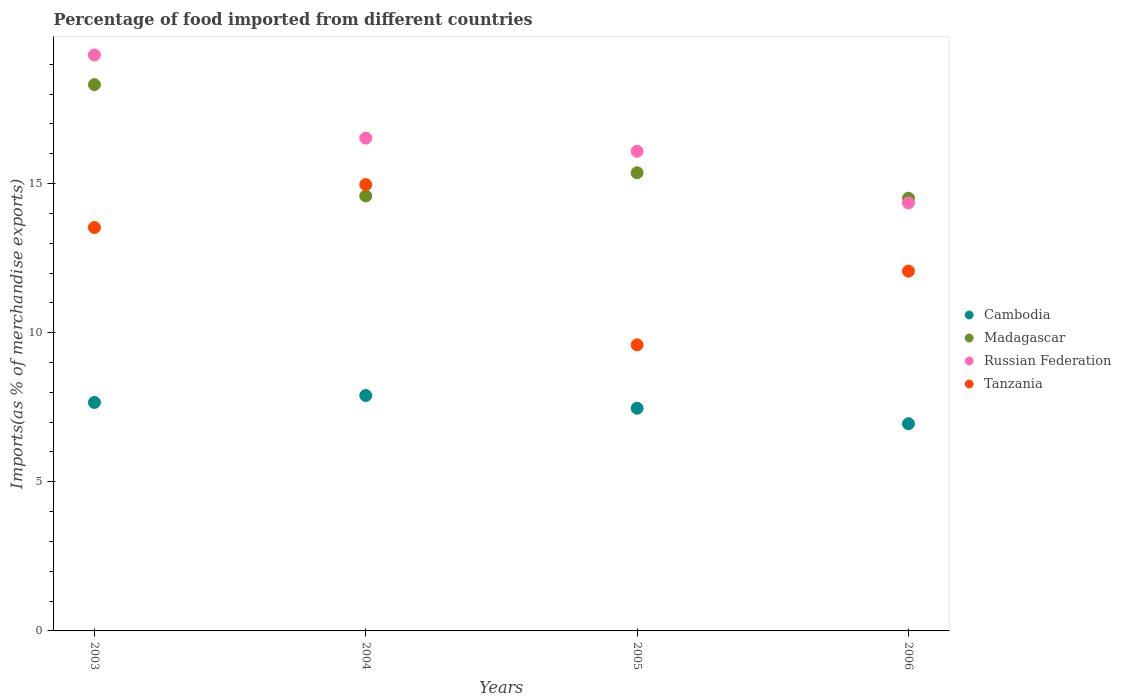How many different coloured dotlines are there?
Offer a terse response. 4. Is the number of dotlines equal to the number of legend labels?
Your answer should be very brief. Yes. What is the percentage of imports to different countries in Tanzania in 2004?
Your answer should be compact. 14.97. Across all years, what is the maximum percentage of imports to different countries in Cambodia?
Your answer should be compact. 7.89. Across all years, what is the minimum percentage of imports to different countries in Madagascar?
Provide a short and direct response. 14.51. What is the total percentage of imports to different countries in Russian Federation in the graph?
Keep it short and to the point. 66.27. What is the difference between the percentage of imports to different countries in Tanzania in 2004 and that in 2006?
Your answer should be very brief. 2.9. What is the difference between the percentage of imports to different countries in Madagascar in 2006 and the percentage of imports to different countries in Tanzania in 2004?
Make the answer very short. -0.46. What is the average percentage of imports to different countries in Madagascar per year?
Ensure brevity in your answer.  15.69. In the year 2004, what is the difference between the percentage of imports to different countries in Madagascar and percentage of imports to different countries in Cambodia?
Give a very brief answer. 6.69. In how many years, is the percentage of imports to different countries in Madagascar greater than 16 %?
Give a very brief answer. 1. What is the ratio of the percentage of imports to different countries in Tanzania in 2003 to that in 2006?
Your answer should be very brief. 1.12. What is the difference between the highest and the second highest percentage of imports to different countries in Russian Federation?
Ensure brevity in your answer.  2.79. What is the difference between the highest and the lowest percentage of imports to different countries in Tanzania?
Make the answer very short. 5.37. Does the percentage of imports to different countries in Madagascar monotonically increase over the years?
Your response must be concise. No. Is the percentage of imports to different countries in Madagascar strictly greater than the percentage of imports to different countries in Tanzania over the years?
Offer a terse response. No. How many years are there in the graph?
Ensure brevity in your answer.  4. Where does the legend appear in the graph?
Your answer should be very brief. Center right. What is the title of the graph?
Your response must be concise. Percentage of food imported from different countries. Does "St. Lucia" appear as one of the legend labels in the graph?
Make the answer very short. No. What is the label or title of the X-axis?
Offer a terse response. Years. What is the label or title of the Y-axis?
Give a very brief answer. Imports(as % of merchandise exports). What is the Imports(as % of merchandise exports) in Cambodia in 2003?
Your response must be concise. 7.66. What is the Imports(as % of merchandise exports) of Madagascar in 2003?
Provide a succinct answer. 18.32. What is the Imports(as % of merchandise exports) of Russian Federation in 2003?
Your answer should be compact. 19.31. What is the Imports(as % of merchandise exports) of Tanzania in 2003?
Offer a very short reply. 13.53. What is the Imports(as % of merchandise exports) in Cambodia in 2004?
Provide a succinct answer. 7.89. What is the Imports(as % of merchandise exports) of Madagascar in 2004?
Keep it short and to the point. 14.59. What is the Imports(as % of merchandise exports) of Russian Federation in 2004?
Provide a short and direct response. 16.52. What is the Imports(as % of merchandise exports) in Tanzania in 2004?
Your answer should be very brief. 14.97. What is the Imports(as % of merchandise exports) in Cambodia in 2005?
Offer a terse response. 7.47. What is the Imports(as % of merchandise exports) in Madagascar in 2005?
Ensure brevity in your answer.  15.36. What is the Imports(as % of merchandise exports) of Russian Federation in 2005?
Make the answer very short. 16.08. What is the Imports(as % of merchandise exports) in Tanzania in 2005?
Make the answer very short. 9.59. What is the Imports(as % of merchandise exports) of Cambodia in 2006?
Offer a very short reply. 6.95. What is the Imports(as % of merchandise exports) of Madagascar in 2006?
Keep it short and to the point. 14.51. What is the Imports(as % of merchandise exports) of Russian Federation in 2006?
Give a very brief answer. 14.35. What is the Imports(as % of merchandise exports) of Tanzania in 2006?
Offer a very short reply. 12.06. Across all years, what is the maximum Imports(as % of merchandise exports) in Cambodia?
Give a very brief answer. 7.89. Across all years, what is the maximum Imports(as % of merchandise exports) in Madagascar?
Offer a very short reply. 18.32. Across all years, what is the maximum Imports(as % of merchandise exports) in Russian Federation?
Provide a succinct answer. 19.31. Across all years, what is the maximum Imports(as % of merchandise exports) of Tanzania?
Your answer should be very brief. 14.97. Across all years, what is the minimum Imports(as % of merchandise exports) of Cambodia?
Your answer should be compact. 6.95. Across all years, what is the minimum Imports(as % of merchandise exports) in Madagascar?
Offer a very short reply. 14.51. Across all years, what is the minimum Imports(as % of merchandise exports) of Russian Federation?
Your response must be concise. 14.35. Across all years, what is the minimum Imports(as % of merchandise exports) of Tanzania?
Offer a terse response. 9.59. What is the total Imports(as % of merchandise exports) of Cambodia in the graph?
Offer a very short reply. 29.97. What is the total Imports(as % of merchandise exports) of Madagascar in the graph?
Give a very brief answer. 62.78. What is the total Imports(as % of merchandise exports) in Russian Federation in the graph?
Provide a succinct answer. 66.27. What is the total Imports(as % of merchandise exports) of Tanzania in the graph?
Your answer should be compact. 50.15. What is the difference between the Imports(as % of merchandise exports) in Cambodia in 2003 and that in 2004?
Your answer should be very brief. -0.23. What is the difference between the Imports(as % of merchandise exports) in Madagascar in 2003 and that in 2004?
Offer a very short reply. 3.73. What is the difference between the Imports(as % of merchandise exports) in Russian Federation in 2003 and that in 2004?
Offer a very short reply. 2.79. What is the difference between the Imports(as % of merchandise exports) in Tanzania in 2003 and that in 2004?
Offer a terse response. -1.44. What is the difference between the Imports(as % of merchandise exports) in Cambodia in 2003 and that in 2005?
Provide a succinct answer. 0.19. What is the difference between the Imports(as % of merchandise exports) in Madagascar in 2003 and that in 2005?
Your response must be concise. 2.95. What is the difference between the Imports(as % of merchandise exports) in Russian Federation in 2003 and that in 2005?
Your answer should be very brief. 3.23. What is the difference between the Imports(as % of merchandise exports) in Tanzania in 2003 and that in 2005?
Your answer should be very brief. 3.93. What is the difference between the Imports(as % of merchandise exports) in Cambodia in 2003 and that in 2006?
Ensure brevity in your answer.  0.71. What is the difference between the Imports(as % of merchandise exports) of Madagascar in 2003 and that in 2006?
Provide a short and direct response. 3.81. What is the difference between the Imports(as % of merchandise exports) of Russian Federation in 2003 and that in 2006?
Offer a terse response. 4.96. What is the difference between the Imports(as % of merchandise exports) in Tanzania in 2003 and that in 2006?
Offer a very short reply. 1.46. What is the difference between the Imports(as % of merchandise exports) in Cambodia in 2004 and that in 2005?
Offer a terse response. 0.43. What is the difference between the Imports(as % of merchandise exports) in Madagascar in 2004 and that in 2005?
Your response must be concise. -0.78. What is the difference between the Imports(as % of merchandise exports) in Russian Federation in 2004 and that in 2005?
Give a very brief answer. 0.44. What is the difference between the Imports(as % of merchandise exports) in Tanzania in 2004 and that in 2005?
Your answer should be very brief. 5.37. What is the difference between the Imports(as % of merchandise exports) in Cambodia in 2004 and that in 2006?
Provide a short and direct response. 0.95. What is the difference between the Imports(as % of merchandise exports) in Madagascar in 2004 and that in 2006?
Ensure brevity in your answer.  0.08. What is the difference between the Imports(as % of merchandise exports) of Russian Federation in 2004 and that in 2006?
Offer a terse response. 2.17. What is the difference between the Imports(as % of merchandise exports) in Tanzania in 2004 and that in 2006?
Your answer should be compact. 2.9. What is the difference between the Imports(as % of merchandise exports) of Cambodia in 2005 and that in 2006?
Ensure brevity in your answer.  0.52. What is the difference between the Imports(as % of merchandise exports) in Madagascar in 2005 and that in 2006?
Your response must be concise. 0.85. What is the difference between the Imports(as % of merchandise exports) of Russian Federation in 2005 and that in 2006?
Keep it short and to the point. 1.73. What is the difference between the Imports(as % of merchandise exports) in Tanzania in 2005 and that in 2006?
Your response must be concise. -2.47. What is the difference between the Imports(as % of merchandise exports) in Cambodia in 2003 and the Imports(as % of merchandise exports) in Madagascar in 2004?
Offer a very short reply. -6.92. What is the difference between the Imports(as % of merchandise exports) in Cambodia in 2003 and the Imports(as % of merchandise exports) in Russian Federation in 2004?
Your response must be concise. -8.86. What is the difference between the Imports(as % of merchandise exports) of Cambodia in 2003 and the Imports(as % of merchandise exports) of Tanzania in 2004?
Ensure brevity in your answer.  -7.3. What is the difference between the Imports(as % of merchandise exports) of Madagascar in 2003 and the Imports(as % of merchandise exports) of Russian Federation in 2004?
Give a very brief answer. 1.79. What is the difference between the Imports(as % of merchandise exports) of Madagascar in 2003 and the Imports(as % of merchandise exports) of Tanzania in 2004?
Give a very brief answer. 3.35. What is the difference between the Imports(as % of merchandise exports) in Russian Federation in 2003 and the Imports(as % of merchandise exports) in Tanzania in 2004?
Your answer should be compact. 4.35. What is the difference between the Imports(as % of merchandise exports) of Cambodia in 2003 and the Imports(as % of merchandise exports) of Madagascar in 2005?
Your answer should be very brief. -7.7. What is the difference between the Imports(as % of merchandise exports) of Cambodia in 2003 and the Imports(as % of merchandise exports) of Russian Federation in 2005?
Your answer should be compact. -8.42. What is the difference between the Imports(as % of merchandise exports) of Cambodia in 2003 and the Imports(as % of merchandise exports) of Tanzania in 2005?
Provide a succinct answer. -1.93. What is the difference between the Imports(as % of merchandise exports) of Madagascar in 2003 and the Imports(as % of merchandise exports) of Russian Federation in 2005?
Ensure brevity in your answer.  2.23. What is the difference between the Imports(as % of merchandise exports) of Madagascar in 2003 and the Imports(as % of merchandise exports) of Tanzania in 2005?
Keep it short and to the point. 8.73. What is the difference between the Imports(as % of merchandise exports) of Russian Federation in 2003 and the Imports(as % of merchandise exports) of Tanzania in 2005?
Keep it short and to the point. 9.72. What is the difference between the Imports(as % of merchandise exports) of Cambodia in 2003 and the Imports(as % of merchandise exports) of Madagascar in 2006?
Make the answer very short. -6.85. What is the difference between the Imports(as % of merchandise exports) of Cambodia in 2003 and the Imports(as % of merchandise exports) of Russian Federation in 2006?
Provide a succinct answer. -6.69. What is the difference between the Imports(as % of merchandise exports) in Cambodia in 2003 and the Imports(as % of merchandise exports) in Tanzania in 2006?
Ensure brevity in your answer.  -4.4. What is the difference between the Imports(as % of merchandise exports) in Madagascar in 2003 and the Imports(as % of merchandise exports) in Russian Federation in 2006?
Give a very brief answer. 3.97. What is the difference between the Imports(as % of merchandise exports) of Madagascar in 2003 and the Imports(as % of merchandise exports) of Tanzania in 2006?
Offer a terse response. 6.25. What is the difference between the Imports(as % of merchandise exports) in Russian Federation in 2003 and the Imports(as % of merchandise exports) in Tanzania in 2006?
Ensure brevity in your answer.  7.25. What is the difference between the Imports(as % of merchandise exports) in Cambodia in 2004 and the Imports(as % of merchandise exports) in Madagascar in 2005?
Keep it short and to the point. -7.47. What is the difference between the Imports(as % of merchandise exports) of Cambodia in 2004 and the Imports(as % of merchandise exports) of Russian Federation in 2005?
Make the answer very short. -8.19. What is the difference between the Imports(as % of merchandise exports) in Cambodia in 2004 and the Imports(as % of merchandise exports) in Tanzania in 2005?
Provide a succinct answer. -1.7. What is the difference between the Imports(as % of merchandise exports) in Madagascar in 2004 and the Imports(as % of merchandise exports) in Russian Federation in 2005?
Your answer should be very brief. -1.5. What is the difference between the Imports(as % of merchandise exports) in Madagascar in 2004 and the Imports(as % of merchandise exports) in Tanzania in 2005?
Your response must be concise. 4.99. What is the difference between the Imports(as % of merchandise exports) in Russian Federation in 2004 and the Imports(as % of merchandise exports) in Tanzania in 2005?
Give a very brief answer. 6.93. What is the difference between the Imports(as % of merchandise exports) of Cambodia in 2004 and the Imports(as % of merchandise exports) of Madagascar in 2006?
Ensure brevity in your answer.  -6.62. What is the difference between the Imports(as % of merchandise exports) of Cambodia in 2004 and the Imports(as % of merchandise exports) of Russian Federation in 2006?
Give a very brief answer. -6.46. What is the difference between the Imports(as % of merchandise exports) of Cambodia in 2004 and the Imports(as % of merchandise exports) of Tanzania in 2006?
Ensure brevity in your answer.  -4.17. What is the difference between the Imports(as % of merchandise exports) in Madagascar in 2004 and the Imports(as % of merchandise exports) in Russian Federation in 2006?
Provide a succinct answer. 0.23. What is the difference between the Imports(as % of merchandise exports) in Madagascar in 2004 and the Imports(as % of merchandise exports) in Tanzania in 2006?
Your answer should be compact. 2.52. What is the difference between the Imports(as % of merchandise exports) of Russian Federation in 2004 and the Imports(as % of merchandise exports) of Tanzania in 2006?
Your answer should be very brief. 4.46. What is the difference between the Imports(as % of merchandise exports) in Cambodia in 2005 and the Imports(as % of merchandise exports) in Madagascar in 2006?
Provide a short and direct response. -7.04. What is the difference between the Imports(as % of merchandise exports) of Cambodia in 2005 and the Imports(as % of merchandise exports) of Russian Federation in 2006?
Make the answer very short. -6.88. What is the difference between the Imports(as % of merchandise exports) of Cambodia in 2005 and the Imports(as % of merchandise exports) of Tanzania in 2006?
Make the answer very short. -4.6. What is the difference between the Imports(as % of merchandise exports) of Madagascar in 2005 and the Imports(as % of merchandise exports) of Russian Federation in 2006?
Offer a terse response. 1.01. What is the difference between the Imports(as % of merchandise exports) of Madagascar in 2005 and the Imports(as % of merchandise exports) of Tanzania in 2006?
Provide a short and direct response. 3.3. What is the difference between the Imports(as % of merchandise exports) in Russian Federation in 2005 and the Imports(as % of merchandise exports) in Tanzania in 2006?
Keep it short and to the point. 4.02. What is the average Imports(as % of merchandise exports) of Cambodia per year?
Offer a very short reply. 7.49. What is the average Imports(as % of merchandise exports) of Madagascar per year?
Provide a succinct answer. 15.69. What is the average Imports(as % of merchandise exports) of Russian Federation per year?
Ensure brevity in your answer.  16.57. What is the average Imports(as % of merchandise exports) in Tanzania per year?
Your answer should be compact. 12.54. In the year 2003, what is the difference between the Imports(as % of merchandise exports) of Cambodia and Imports(as % of merchandise exports) of Madagascar?
Make the answer very short. -10.66. In the year 2003, what is the difference between the Imports(as % of merchandise exports) in Cambodia and Imports(as % of merchandise exports) in Russian Federation?
Make the answer very short. -11.65. In the year 2003, what is the difference between the Imports(as % of merchandise exports) in Cambodia and Imports(as % of merchandise exports) in Tanzania?
Provide a short and direct response. -5.87. In the year 2003, what is the difference between the Imports(as % of merchandise exports) in Madagascar and Imports(as % of merchandise exports) in Russian Federation?
Keep it short and to the point. -0.99. In the year 2003, what is the difference between the Imports(as % of merchandise exports) of Madagascar and Imports(as % of merchandise exports) of Tanzania?
Your response must be concise. 4.79. In the year 2003, what is the difference between the Imports(as % of merchandise exports) in Russian Federation and Imports(as % of merchandise exports) in Tanzania?
Make the answer very short. 5.78. In the year 2004, what is the difference between the Imports(as % of merchandise exports) in Cambodia and Imports(as % of merchandise exports) in Madagascar?
Your response must be concise. -6.69. In the year 2004, what is the difference between the Imports(as % of merchandise exports) of Cambodia and Imports(as % of merchandise exports) of Russian Federation?
Offer a very short reply. -8.63. In the year 2004, what is the difference between the Imports(as % of merchandise exports) of Cambodia and Imports(as % of merchandise exports) of Tanzania?
Ensure brevity in your answer.  -7.07. In the year 2004, what is the difference between the Imports(as % of merchandise exports) of Madagascar and Imports(as % of merchandise exports) of Russian Federation?
Keep it short and to the point. -1.94. In the year 2004, what is the difference between the Imports(as % of merchandise exports) of Madagascar and Imports(as % of merchandise exports) of Tanzania?
Make the answer very short. -0.38. In the year 2004, what is the difference between the Imports(as % of merchandise exports) in Russian Federation and Imports(as % of merchandise exports) in Tanzania?
Offer a terse response. 1.56. In the year 2005, what is the difference between the Imports(as % of merchandise exports) of Cambodia and Imports(as % of merchandise exports) of Madagascar?
Provide a short and direct response. -7.9. In the year 2005, what is the difference between the Imports(as % of merchandise exports) in Cambodia and Imports(as % of merchandise exports) in Russian Federation?
Make the answer very short. -8.62. In the year 2005, what is the difference between the Imports(as % of merchandise exports) in Cambodia and Imports(as % of merchandise exports) in Tanzania?
Your answer should be very brief. -2.13. In the year 2005, what is the difference between the Imports(as % of merchandise exports) of Madagascar and Imports(as % of merchandise exports) of Russian Federation?
Keep it short and to the point. -0.72. In the year 2005, what is the difference between the Imports(as % of merchandise exports) in Madagascar and Imports(as % of merchandise exports) in Tanzania?
Keep it short and to the point. 5.77. In the year 2005, what is the difference between the Imports(as % of merchandise exports) in Russian Federation and Imports(as % of merchandise exports) in Tanzania?
Your answer should be very brief. 6.49. In the year 2006, what is the difference between the Imports(as % of merchandise exports) in Cambodia and Imports(as % of merchandise exports) in Madagascar?
Ensure brevity in your answer.  -7.56. In the year 2006, what is the difference between the Imports(as % of merchandise exports) of Cambodia and Imports(as % of merchandise exports) of Russian Federation?
Provide a succinct answer. -7.4. In the year 2006, what is the difference between the Imports(as % of merchandise exports) of Cambodia and Imports(as % of merchandise exports) of Tanzania?
Your answer should be compact. -5.12. In the year 2006, what is the difference between the Imports(as % of merchandise exports) in Madagascar and Imports(as % of merchandise exports) in Russian Federation?
Ensure brevity in your answer.  0.16. In the year 2006, what is the difference between the Imports(as % of merchandise exports) of Madagascar and Imports(as % of merchandise exports) of Tanzania?
Your answer should be compact. 2.45. In the year 2006, what is the difference between the Imports(as % of merchandise exports) in Russian Federation and Imports(as % of merchandise exports) in Tanzania?
Provide a short and direct response. 2.29. What is the ratio of the Imports(as % of merchandise exports) in Cambodia in 2003 to that in 2004?
Offer a terse response. 0.97. What is the ratio of the Imports(as % of merchandise exports) of Madagascar in 2003 to that in 2004?
Your response must be concise. 1.26. What is the ratio of the Imports(as % of merchandise exports) in Russian Federation in 2003 to that in 2004?
Ensure brevity in your answer.  1.17. What is the ratio of the Imports(as % of merchandise exports) in Tanzania in 2003 to that in 2004?
Make the answer very short. 0.9. What is the ratio of the Imports(as % of merchandise exports) in Cambodia in 2003 to that in 2005?
Ensure brevity in your answer.  1.03. What is the ratio of the Imports(as % of merchandise exports) in Madagascar in 2003 to that in 2005?
Provide a short and direct response. 1.19. What is the ratio of the Imports(as % of merchandise exports) of Russian Federation in 2003 to that in 2005?
Your answer should be very brief. 1.2. What is the ratio of the Imports(as % of merchandise exports) in Tanzania in 2003 to that in 2005?
Your response must be concise. 1.41. What is the ratio of the Imports(as % of merchandise exports) in Cambodia in 2003 to that in 2006?
Offer a terse response. 1.1. What is the ratio of the Imports(as % of merchandise exports) of Madagascar in 2003 to that in 2006?
Your response must be concise. 1.26. What is the ratio of the Imports(as % of merchandise exports) in Russian Federation in 2003 to that in 2006?
Ensure brevity in your answer.  1.35. What is the ratio of the Imports(as % of merchandise exports) in Tanzania in 2003 to that in 2006?
Offer a terse response. 1.12. What is the ratio of the Imports(as % of merchandise exports) of Cambodia in 2004 to that in 2005?
Your answer should be very brief. 1.06. What is the ratio of the Imports(as % of merchandise exports) in Madagascar in 2004 to that in 2005?
Your answer should be compact. 0.95. What is the ratio of the Imports(as % of merchandise exports) in Russian Federation in 2004 to that in 2005?
Make the answer very short. 1.03. What is the ratio of the Imports(as % of merchandise exports) in Tanzania in 2004 to that in 2005?
Provide a succinct answer. 1.56. What is the ratio of the Imports(as % of merchandise exports) of Cambodia in 2004 to that in 2006?
Offer a terse response. 1.14. What is the ratio of the Imports(as % of merchandise exports) of Madagascar in 2004 to that in 2006?
Keep it short and to the point. 1.01. What is the ratio of the Imports(as % of merchandise exports) of Russian Federation in 2004 to that in 2006?
Your answer should be very brief. 1.15. What is the ratio of the Imports(as % of merchandise exports) of Tanzania in 2004 to that in 2006?
Make the answer very short. 1.24. What is the ratio of the Imports(as % of merchandise exports) of Cambodia in 2005 to that in 2006?
Offer a very short reply. 1.07. What is the ratio of the Imports(as % of merchandise exports) in Madagascar in 2005 to that in 2006?
Provide a succinct answer. 1.06. What is the ratio of the Imports(as % of merchandise exports) in Russian Federation in 2005 to that in 2006?
Ensure brevity in your answer.  1.12. What is the ratio of the Imports(as % of merchandise exports) of Tanzania in 2005 to that in 2006?
Offer a very short reply. 0.8. What is the difference between the highest and the second highest Imports(as % of merchandise exports) in Cambodia?
Your answer should be very brief. 0.23. What is the difference between the highest and the second highest Imports(as % of merchandise exports) of Madagascar?
Your answer should be compact. 2.95. What is the difference between the highest and the second highest Imports(as % of merchandise exports) in Russian Federation?
Keep it short and to the point. 2.79. What is the difference between the highest and the second highest Imports(as % of merchandise exports) in Tanzania?
Your answer should be compact. 1.44. What is the difference between the highest and the lowest Imports(as % of merchandise exports) in Cambodia?
Your answer should be very brief. 0.95. What is the difference between the highest and the lowest Imports(as % of merchandise exports) of Madagascar?
Ensure brevity in your answer.  3.81. What is the difference between the highest and the lowest Imports(as % of merchandise exports) in Russian Federation?
Give a very brief answer. 4.96. What is the difference between the highest and the lowest Imports(as % of merchandise exports) of Tanzania?
Your answer should be compact. 5.37. 